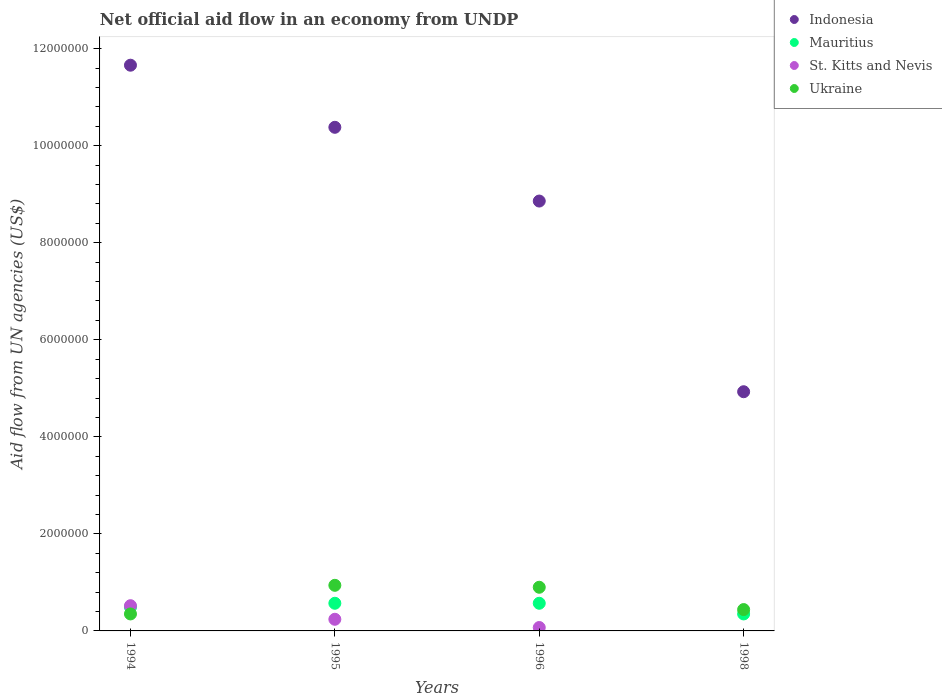How many different coloured dotlines are there?
Give a very brief answer. 4. Is the number of dotlines equal to the number of legend labels?
Your response must be concise. No. Across all years, what is the maximum net official aid flow in St. Kitts and Nevis?
Give a very brief answer. 5.20e+05. Across all years, what is the minimum net official aid flow in St. Kitts and Nevis?
Your answer should be very brief. 0. In which year was the net official aid flow in Mauritius maximum?
Provide a succinct answer. 1995. What is the total net official aid flow in Ukraine in the graph?
Make the answer very short. 2.63e+06. What is the average net official aid flow in Indonesia per year?
Make the answer very short. 8.96e+06. In the year 1994, what is the difference between the net official aid flow in Indonesia and net official aid flow in Mauritius?
Offer a very short reply. 1.12e+07. What is the ratio of the net official aid flow in Mauritius in 1994 to that in 1995?
Offer a very short reply. 0.86. What is the difference between the highest and the lowest net official aid flow in Mauritius?
Your response must be concise. 2.20e+05. In how many years, is the net official aid flow in Ukraine greater than the average net official aid flow in Ukraine taken over all years?
Offer a terse response. 2. Does the net official aid flow in St. Kitts and Nevis monotonically increase over the years?
Your answer should be very brief. No. Is the net official aid flow in St. Kitts and Nevis strictly greater than the net official aid flow in Ukraine over the years?
Keep it short and to the point. No. How many years are there in the graph?
Your answer should be very brief. 4. Does the graph contain grids?
Provide a succinct answer. No. Where does the legend appear in the graph?
Ensure brevity in your answer.  Top right. How are the legend labels stacked?
Your response must be concise. Vertical. What is the title of the graph?
Your answer should be compact. Net official aid flow in an economy from UNDP. What is the label or title of the X-axis?
Offer a terse response. Years. What is the label or title of the Y-axis?
Offer a very short reply. Aid flow from UN agencies (US$). What is the Aid flow from UN agencies (US$) in Indonesia in 1994?
Make the answer very short. 1.17e+07. What is the Aid flow from UN agencies (US$) in St. Kitts and Nevis in 1994?
Provide a succinct answer. 5.20e+05. What is the Aid flow from UN agencies (US$) of Ukraine in 1994?
Offer a very short reply. 3.50e+05. What is the Aid flow from UN agencies (US$) in Indonesia in 1995?
Your answer should be very brief. 1.04e+07. What is the Aid flow from UN agencies (US$) in Mauritius in 1995?
Ensure brevity in your answer.  5.70e+05. What is the Aid flow from UN agencies (US$) in St. Kitts and Nevis in 1995?
Your answer should be compact. 2.40e+05. What is the Aid flow from UN agencies (US$) in Ukraine in 1995?
Your answer should be very brief. 9.40e+05. What is the Aid flow from UN agencies (US$) of Indonesia in 1996?
Make the answer very short. 8.86e+06. What is the Aid flow from UN agencies (US$) of Mauritius in 1996?
Provide a short and direct response. 5.70e+05. What is the Aid flow from UN agencies (US$) of Ukraine in 1996?
Provide a succinct answer. 9.00e+05. What is the Aid flow from UN agencies (US$) of Indonesia in 1998?
Keep it short and to the point. 4.93e+06. What is the Aid flow from UN agencies (US$) of Mauritius in 1998?
Provide a short and direct response. 3.50e+05. What is the Aid flow from UN agencies (US$) in St. Kitts and Nevis in 1998?
Your answer should be very brief. 0. Across all years, what is the maximum Aid flow from UN agencies (US$) of Indonesia?
Make the answer very short. 1.17e+07. Across all years, what is the maximum Aid flow from UN agencies (US$) in Mauritius?
Your answer should be very brief. 5.70e+05. Across all years, what is the maximum Aid flow from UN agencies (US$) of St. Kitts and Nevis?
Provide a succinct answer. 5.20e+05. Across all years, what is the maximum Aid flow from UN agencies (US$) of Ukraine?
Your response must be concise. 9.40e+05. Across all years, what is the minimum Aid flow from UN agencies (US$) in Indonesia?
Your answer should be very brief. 4.93e+06. Across all years, what is the minimum Aid flow from UN agencies (US$) in St. Kitts and Nevis?
Make the answer very short. 0. Across all years, what is the minimum Aid flow from UN agencies (US$) in Ukraine?
Your response must be concise. 3.50e+05. What is the total Aid flow from UN agencies (US$) in Indonesia in the graph?
Provide a succinct answer. 3.58e+07. What is the total Aid flow from UN agencies (US$) in Mauritius in the graph?
Offer a terse response. 1.98e+06. What is the total Aid flow from UN agencies (US$) in St. Kitts and Nevis in the graph?
Provide a succinct answer. 8.30e+05. What is the total Aid flow from UN agencies (US$) of Ukraine in the graph?
Your answer should be compact. 2.63e+06. What is the difference between the Aid flow from UN agencies (US$) of Indonesia in 1994 and that in 1995?
Your response must be concise. 1.28e+06. What is the difference between the Aid flow from UN agencies (US$) of Mauritius in 1994 and that in 1995?
Keep it short and to the point. -8.00e+04. What is the difference between the Aid flow from UN agencies (US$) in St. Kitts and Nevis in 1994 and that in 1995?
Offer a terse response. 2.80e+05. What is the difference between the Aid flow from UN agencies (US$) of Ukraine in 1994 and that in 1995?
Give a very brief answer. -5.90e+05. What is the difference between the Aid flow from UN agencies (US$) of Indonesia in 1994 and that in 1996?
Your answer should be very brief. 2.80e+06. What is the difference between the Aid flow from UN agencies (US$) in Ukraine in 1994 and that in 1996?
Keep it short and to the point. -5.50e+05. What is the difference between the Aid flow from UN agencies (US$) of Indonesia in 1994 and that in 1998?
Provide a succinct answer. 6.73e+06. What is the difference between the Aid flow from UN agencies (US$) in Indonesia in 1995 and that in 1996?
Offer a very short reply. 1.52e+06. What is the difference between the Aid flow from UN agencies (US$) in Mauritius in 1995 and that in 1996?
Offer a very short reply. 0. What is the difference between the Aid flow from UN agencies (US$) in Ukraine in 1995 and that in 1996?
Your answer should be compact. 4.00e+04. What is the difference between the Aid flow from UN agencies (US$) in Indonesia in 1995 and that in 1998?
Give a very brief answer. 5.45e+06. What is the difference between the Aid flow from UN agencies (US$) of Mauritius in 1995 and that in 1998?
Keep it short and to the point. 2.20e+05. What is the difference between the Aid flow from UN agencies (US$) of Indonesia in 1996 and that in 1998?
Give a very brief answer. 3.93e+06. What is the difference between the Aid flow from UN agencies (US$) in Mauritius in 1996 and that in 1998?
Provide a short and direct response. 2.20e+05. What is the difference between the Aid flow from UN agencies (US$) in Ukraine in 1996 and that in 1998?
Provide a short and direct response. 4.60e+05. What is the difference between the Aid flow from UN agencies (US$) of Indonesia in 1994 and the Aid flow from UN agencies (US$) of Mauritius in 1995?
Provide a short and direct response. 1.11e+07. What is the difference between the Aid flow from UN agencies (US$) of Indonesia in 1994 and the Aid flow from UN agencies (US$) of St. Kitts and Nevis in 1995?
Keep it short and to the point. 1.14e+07. What is the difference between the Aid flow from UN agencies (US$) in Indonesia in 1994 and the Aid flow from UN agencies (US$) in Ukraine in 1995?
Provide a short and direct response. 1.07e+07. What is the difference between the Aid flow from UN agencies (US$) of Mauritius in 1994 and the Aid flow from UN agencies (US$) of Ukraine in 1995?
Provide a short and direct response. -4.50e+05. What is the difference between the Aid flow from UN agencies (US$) in St. Kitts and Nevis in 1994 and the Aid flow from UN agencies (US$) in Ukraine in 1995?
Your answer should be very brief. -4.20e+05. What is the difference between the Aid flow from UN agencies (US$) of Indonesia in 1994 and the Aid flow from UN agencies (US$) of Mauritius in 1996?
Make the answer very short. 1.11e+07. What is the difference between the Aid flow from UN agencies (US$) in Indonesia in 1994 and the Aid flow from UN agencies (US$) in St. Kitts and Nevis in 1996?
Your answer should be compact. 1.16e+07. What is the difference between the Aid flow from UN agencies (US$) in Indonesia in 1994 and the Aid flow from UN agencies (US$) in Ukraine in 1996?
Give a very brief answer. 1.08e+07. What is the difference between the Aid flow from UN agencies (US$) in Mauritius in 1994 and the Aid flow from UN agencies (US$) in Ukraine in 1996?
Your answer should be compact. -4.10e+05. What is the difference between the Aid flow from UN agencies (US$) in St. Kitts and Nevis in 1994 and the Aid flow from UN agencies (US$) in Ukraine in 1996?
Your answer should be very brief. -3.80e+05. What is the difference between the Aid flow from UN agencies (US$) of Indonesia in 1994 and the Aid flow from UN agencies (US$) of Mauritius in 1998?
Give a very brief answer. 1.13e+07. What is the difference between the Aid flow from UN agencies (US$) in Indonesia in 1994 and the Aid flow from UN agencies (US$) in Ukraine in 1998?
Your answer should be compact. 1.12e+07. What is the difference between the Aid flow from UN agencies (US$) in Mauritius in 1994 and the Aid flow from UN agencies (US$) in Ukraine in 1998?
Make the answer very short. 5.00e+04. What is the difference between the Aid flow from UN agencies (US$) in St. Kitts and Nevis in 1994 and the Aid flow from UN agencies (US$) in Ukraine in 1998?
Provide a succinct answer. 8.00e+04. What is the difference between the Aid flow from UN agencies (US$) in Indonesia in 1995 and the Aid flow from UN agencies (US$) in Mauritius in 1996?
Ensure brevity in your answer.  9.81e+06. What is the difference between the Aid flow from UN agencies (US$) of Indonesia in 1995 and the Aid flow from UN agencies (US$) of St. Kitts and Nevis in 1996?
Your response must be concise. 1.03e+07. What is the difference between the Aid flow from UN agencies (US$) of Indonesia in 1995 and the Aid flow from UN agencies (US$) of Ukraine in 1996?
Ensure brevity in your answer.  9.48e+06. What is the difference between the Aid flow from UN agencies (US$) of Mauritius in 1995 and the Aid flow from UN agencies (US$) of St. Kitts and Nevis in 1996?
Give a very brief answer. 5.00e+05. What is the difference between the Aid flow from UN agencies (US$) in Mauritius in 1995 and the Aid flow from UN agencies (US$) in Ukraine in 1996?
Your answer should be very brief. -3.30e+05. What is the difference between the Aid flow from UN agencies (US$) of St. Kitts and Nevis in 1995 and the Aid flow from UN agencies (US$) of Ukraine in 1996?
Your answer should be very brief. -6.60e+05. What is the difference between the Aid flow from UN agencies (US$) in Indonesia in 1995 and the Aid flow from UN agencies (US$) in Mauritius in 1998?
Offer a very short reply. 1.00e+07. What is the difference between the Aid flow from UN agencies (US$) in Indonesia in 1995 and the Aid flow from UN agencies (US$) in Ukraine in 1998?
Your response must be concise. 9.94e+06. What is the difference between the Aid flow from UN agencies (US$) of St. Kitts and Nevis in 1995 and the Aid flow from UN agencies (US$) of Ukraine in 1998?
Your response must be concise. -2.00e+05. What is the difference between the Aid flow from UN agencies (US$) of Indonesia in 1996 and the Aid flow from UN agencies (US$) of Mauritius in 1998?
Your answer should be very brief. 8.51e+06. What is the difference between the Aid flow from UN agencies (US$) in Indonesia in 1996 and the Aid flow from UN agencies (US$) in Ukraine in 1998?
Make the answer very short. 8.42e+06. What is the difference between the Aid flow from UN agencies (US$) in Mauritius in 1996 and the Aid flow from UN agencies (US$) in Ukraine in 1998?
Keep it short and to the point. 1.30e+05. What is the difference between the Aid flow from UN agencies (US$) of St. Kitts and Nevis in 1996 and the Aid flow from UN agencies (US$) of Ukraine in 1998?
Offer a very short reply. -3.70e+05. What is the average Aid flow from UN agencies (US$) of Indonesia per year?
Provide a short and direct response. 8.96e+06. What is the average Aid flow from UN agencies (US$) in Mauritius per year?
Provide a succinct answer. 4.95e+05. What is the average Aid flow from UN agencies (US$) in St. Kitts and Nevis per year?
Offer a terse response. 2.08e+05. What is the average Aid flow from UN agencies (US$) in Ukraine per year?
Give a very brief answer. 6.58e+05. In the year 1994, what is the difference between the Aid flow from UN agencies (US$) of Indonesia and Aid flow from UN agencies (US$) of Mauritius?
Offer a terse response. 1.12e+07. In the year 1994, what is the difference between the Aid flow from UN agencies (US$) in Indonesia and Aid flow from UN agencies (US$) in St. Kitts and Nevis?
Provide a short and direct response. 1.11e+07. In the year 1994, what is the difference between the Aid flow from UN agencies (US$) of Indonesia and Aid flow from UN agencies (US$) of Ukraine?
Ensure brevity in your answer.  1.13e+07. In the year 1994, what is the difference between the Aid flow from UN agencies (US$) in Mauritius and Aid flow from UN agencies (US$) in St. Kitts and Nevis?
Your answer should be compact. -3.00e+04. In the year 1994, what is the difference between the Aid flow from UN agencies (US$) in St. Kitts and Nevis and Aid flow from UN agencies (US$) in Ukraine?
Make the answer very short. 1.70e+05. In the year 1995, what is the difference between the Aid flow from UN agencies (US$) of Indonesia and Aid flow from UN agencies (US$) of Mauritius?
Your response must be concise. 9.81e+06. In the year 1995, what is the difference between the Aid flow from UN agencies (US$) in Indonesia and Aid flow from UN agencies (US$) in St. Kitts and Nevis?
Offer a very short reply. 1.01e+07. In the year 1995, what is the difference between the Aid flow from UN agencies (US$) in Indonesia and Aid flow from UN agencies (US$) in Ukraine?
Your answer should be compact. 9.44e+06. In the year 1995, what is the difference between the Aid flow from UN agencies (US$) in Mauritius and Aid flow from UN agencies (US$) in Ukraine?
Keep it short and to the point. -3.70e+05. In the year 1995, what is the difference between the Aid flow from UN agencies (US$) in St. Kitts and Nevis and Aid flow from UN agencies (US$) in Ukraine?
Provide a succinct answer. -7.00e+05. In the year 1996, what is the difference between the Aid flow from UN agencies (US$) of Indonesia and Aid flow from UN agencies (US$) of Mauritius?
Your answer should be compact. 8.29e+06. In the year 1996, what is the difference between the Aid flow from UN agencies (US$) of Indonesia and Aid flow from UN agencies (US$) of St. Kitts and Nevis?
Your response must be concise. 8.79e+06. In the year 1996, what is the difference between the Aid flow from UN agencies (US$) in Indonesia and Aid flow from UN agencies (US$) in Ukraine?
Provide a short and direct response. 7.96e+06. In the year 1996, what is the difference between the Aid flow from UN agencies (US$) of Mauritius and Aid flow from UN agencies (US$) of St. Kitts and Nevis?
Ensure brevity in your answer.  5.00e+05. In the year 1996, what is the difference between the Aid flow from UN agencies (US$) in Mauritius and Aid flow from UN agencies (US$) in Ukraine?
Provide a succinct answer. -3.30e+05. In the year 1996, what is the difference between the Aid flow from UN agencies (US$) of St. Kitts and Nevis and Aid flow from UN agencies (US$) of Ukraine?
Keep it short and to the point. -8.30e+05. In the year 1998, what is the difference between the Aid flow from UN agencies (US$) in Indonesia and Aid flow from UN agencies (US$) in Mauritius?
Keep it short and to the point. 4.58e+06. In the year 1998, what is the difference between the Aid flow from UN agencies (US$) in Indonesia and Aid flow from UN agencies (US$) in Ukraine?
Your answer should be compact. 4.49e+06. What is the ratio of the Aid flow from UN agencies (US$) in Indonesia in 1994 to that in 1995?
Your answer should be very brief. 1.12. What is the ratio of the Aid flow from UN agencies (US$) of Mauritius in 1994 to that in 1995?
Your response must be concise. 0.86. What is the ratio of the Aid flow from UN agencies (US$) of St. Kitts and Nevis in 1994 to that in 1995?
Ensure brevity in your answer.  2.17. What is the ratio of the Aid flow from UN agencies (US$) of Ukraine in 1994 to that in 1995?
Keep it short and to the point. 0.37. What is the ratio of the Aid flow from UN agencies (US$) in Indonesia in 1994 to that in 1996?
Your answer should be very brief. 1.32. What is the ratio of the Aid flow from UN agencies (US$) of Mauritius in 1994 to that in 1996?
Your answer should be compact. 0.86. What is the ratio of the Aid flow from UN agencies (US$) in St. Kitts and Nevis in 1994 to that in 1996?
Your answer should be very brief. 7.43. What is the ratio of the Aid flow from UN agencies (US$) in Ukraine in 1994 to that in 1996?
Your answer should be compact. 0.39. What is the ratio of the Aid flow from UN agencies (US$) in Indonesia in 1994 to that in 1998?
Provide a short and direct response. 2.37. What is the ratio of the Aid flow from UN agencies (US$) of Ukraine in 1994 to that in 1998?
Offer a terse response. 0.8. What is the ratio of the Aid flow from UN agencies (US$) in Indonesia in 1995 to that in 1996?
Offer a very short reply. 1.17. What is the ratio of the Aid flow from UN agencies (US$) in Mauritius in 1995 to that in 1996?
Your answer should be compact. 1. What is the ratio of the Aid flow from UN agencies (US$) in St. Kitts and Nevis in 1995 to that in 1996?
Provide a short and direct response. 3.43. What is the ratio of the Aid flow from UN agencies (US$) of Ukraine in 1995 to that in 1996?
Your response must be concise. 1.04. What is the ratio of the Aid flow from UN agencies (US$) in Indonesia in 1995 to that in 1998?
Keep it short and to the point. 2.11. What is the ratio of the Aid flow from UN agencies (US$) in Mauritius in 1995 to that in 1998?
Make the answer very short. 1.63. What is the ratio of the Aid flow from UN agencies (US$) in Ukraine in 1995 to that in 1998?
Offer a very short reply. 2.14. What is the ratio of the Aid flow from UN agencies (US$) of Indonesia in 1996 to that in 1998?
Give a very brief answer. 1.8. What is the ratio of the Aid flow from UN agencies (US$) of Mauritius in 1996 to that in 1998?
Keep it short and to the point. 1.63. What is the ratio of the Aid flow from UN agencies (US$) in Ukraine in 1996 to that in 1998?
Offer a very short reply. 2.05. What is the difference between the highest and the second highest Aid flow from UN agencies (US$) in Indonesia?
Your answer should be compact. 1.28e+06. What is the difference between the highest and the second highest Aid flow from UN agencies (US$) in St. Kitts and Nevis?
Provide a succinct answer. 2.80e+05. What is the difference between the highest and the second highest Aid flow from UN agencies (US$) in Ukraine?
Your answer should be compact. 4.00e+04. What is the difference between the highest and the lowest Aid flow from UN agencies (US$) of Indonesia?
Give a very brief answer. 6.73e+06. What is the difference between the highest and the lowest Aid flow from UN agencies (US$) of Mauritius?
Ensure brevity in your answer.  2.20e+05. What is the difference between the highest and the lowest Aid flow from UN agencies (US$) of St. Kitts and Nevis?
Your answer should be very brief. 5.20e+05. What is the difference between the highest and the lowest Aid flow from UN agencies (US$) of Ukraine?
Your response must be concise. 5.90e+05. 